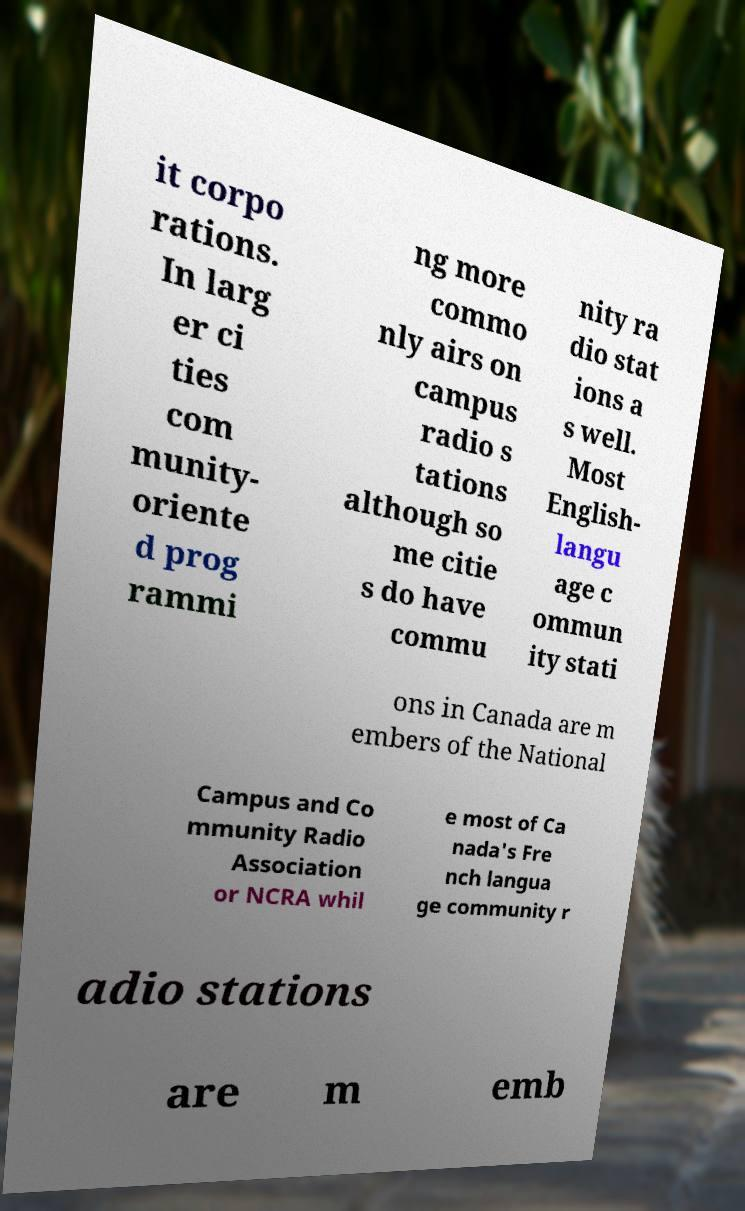Could you extract and type out the text from this image? it corpo rations. In larg er ci ties com munity- oriente d prog rammi ng more commo nly airs on campus radio s tations although so me citie s do have commu nity ra dio stat ions a s well. Most English- langu age c ommun ity stati ons in Canada are m embers of the National Campus and Co mmunity Radio Association or NCRA whil e most of Ca nada's Fre nch langua ge community r adio stations are m emb 